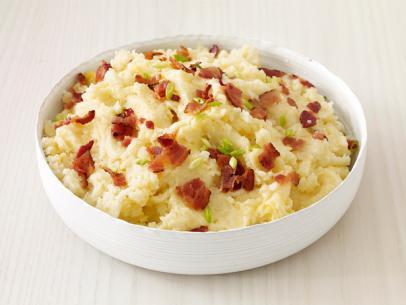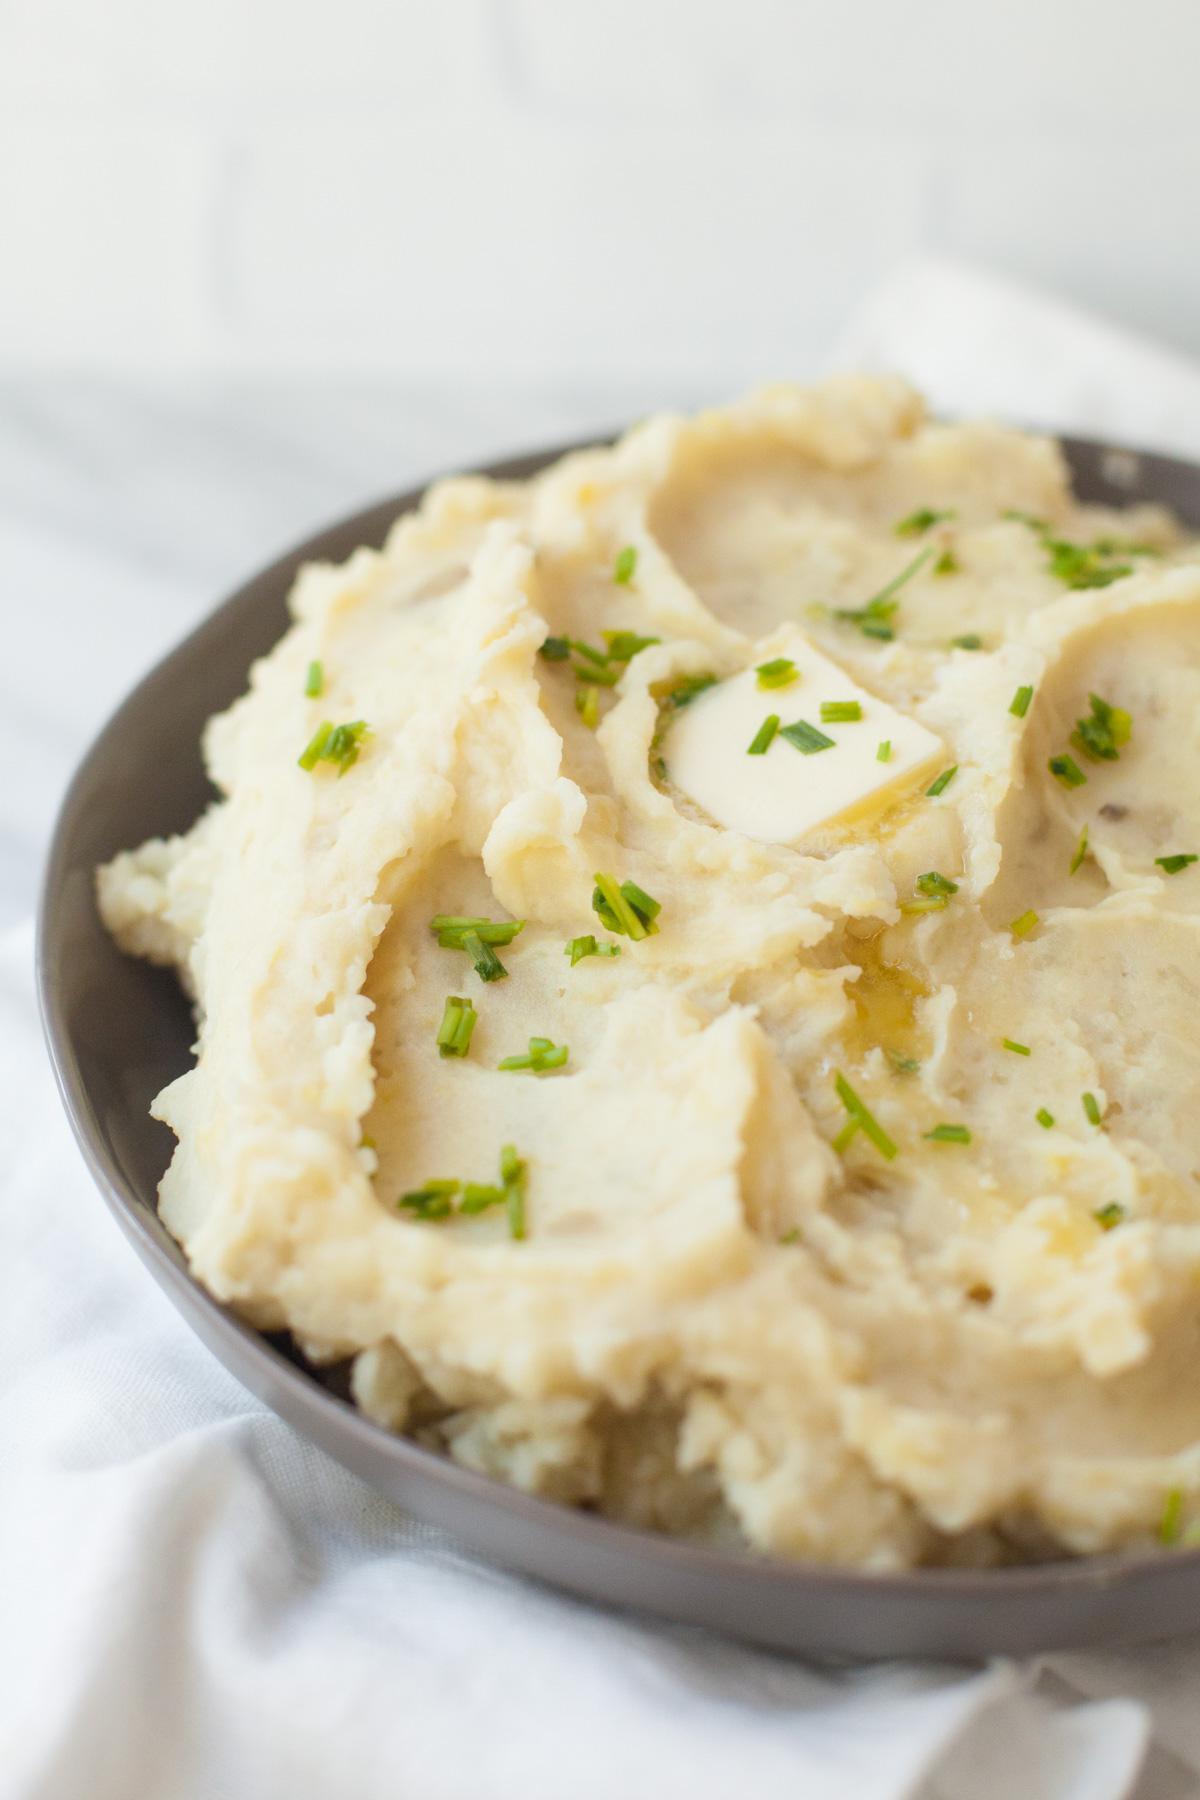The first image is the image on the left, the second image is the image on the right. For the images displayed, is the sentence "Silverware is shown near the bowl in one of the images." factually correct? Answer yes or no. No. The first image is the image on the left, the second image is the image on the right. For the images displayed, is the sentence "An item of silverware is on a napkin that also holds a round white dish containing mashed potatoes." factually correct? Answer yes or no. No. 